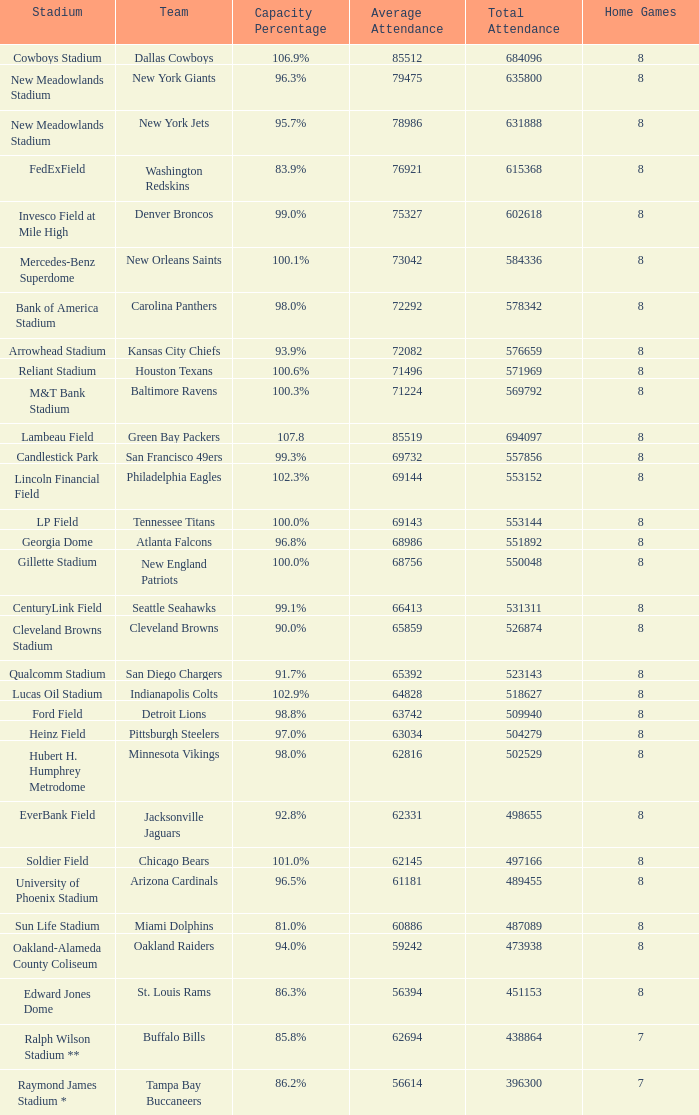How many average attendance has a capacity percentage of 96.5% 1.0. 